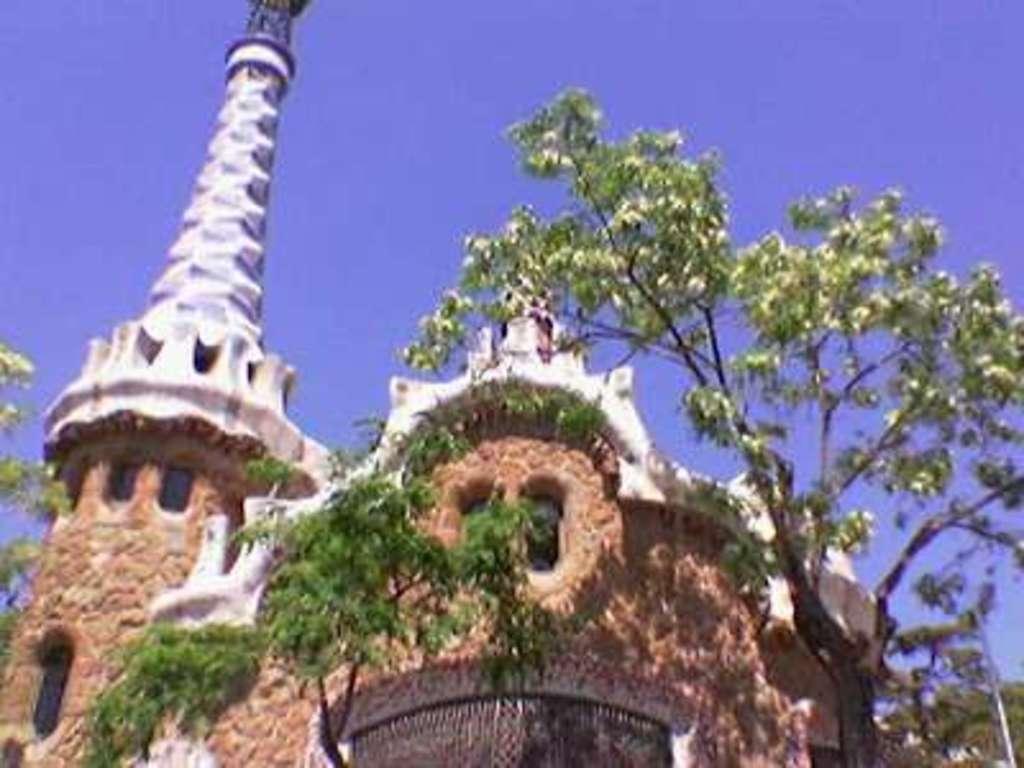Describe this image in one or two sentences. In this picture we can see a building, gate, trees and in the background we can see the sky. 